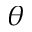<formula> <loc_0><loc_0><loc_500><loc_500>\theta</formula> 